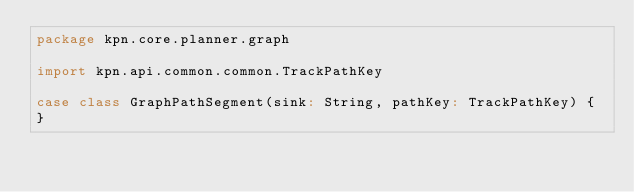<code> <loc_0><loc_0><loc_500><loc_500><_Scala_>package kpn.core.planner.graph

import kpn.api.common.common.TrackPathKey

case class GraphPathSegment(sink: String, pathKey: TrackPathKey) {
}
</code> 